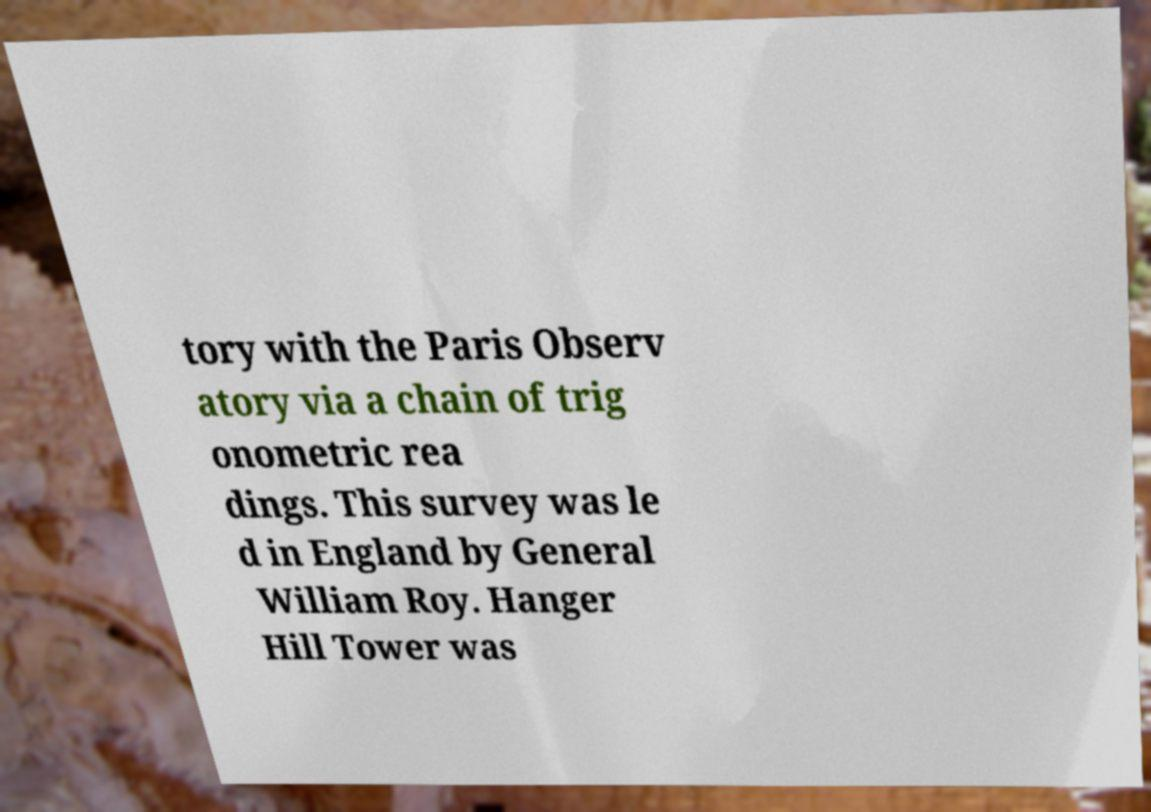Could you extract and type out the text from this image? tory with the Paris Observ atory via a chain of trig onometric rea dings. This survey was le d in England by General William Roy. Hanger Hill Tower was 